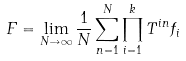Convert formula to latex. <formula><loc_0><loc_0><loc_500><loc_500>F = \lim _ { N \to \infty } \frac { 1 } { N } \sum _ { n = 1 } ^ { N } \prod _ { i = 1 } ^ { k } T ^ { i n } f _ { i }</formula> 